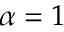Convert formula to latex. <formula><loc_0><loc_0><loc_500><loc_500>\alpha = 1</formula> 